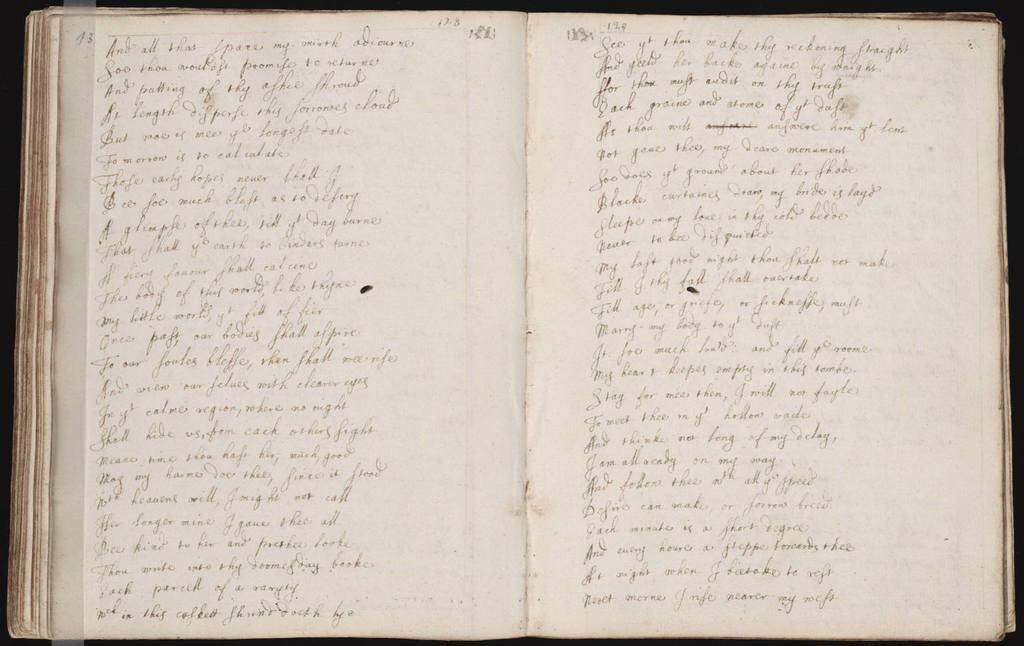<image>
Share a concise interpretation of the image provided. a book opened up to page 128 with handwriting on it 